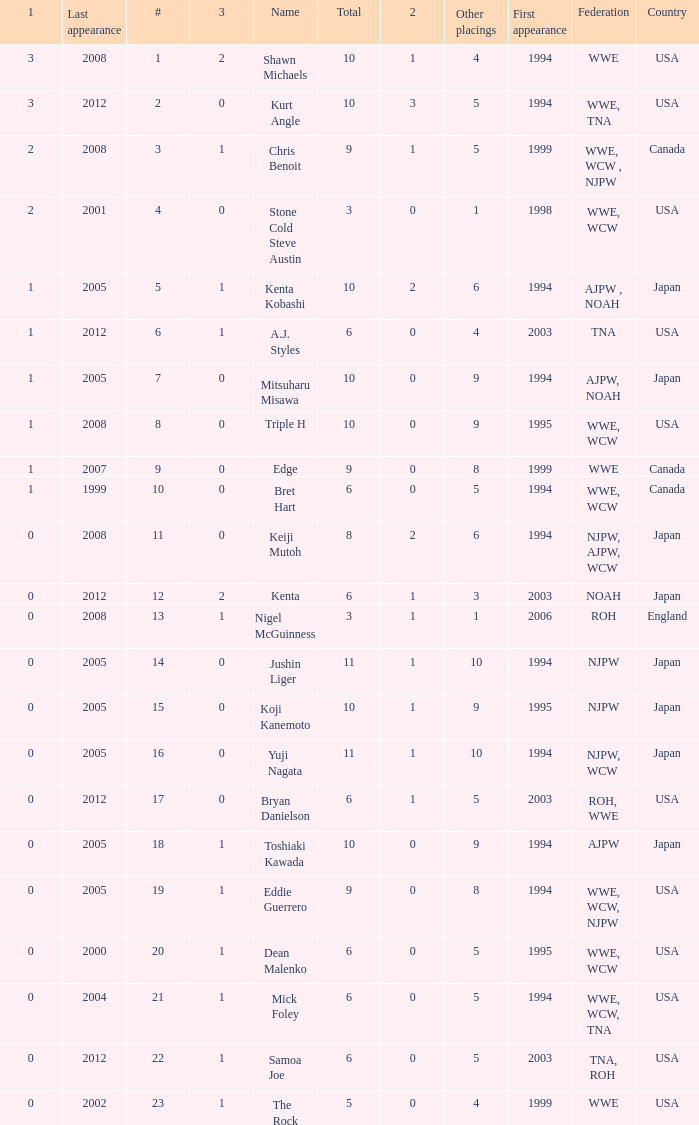What are the rank/s of Eddie Guerrero? 19.0. 